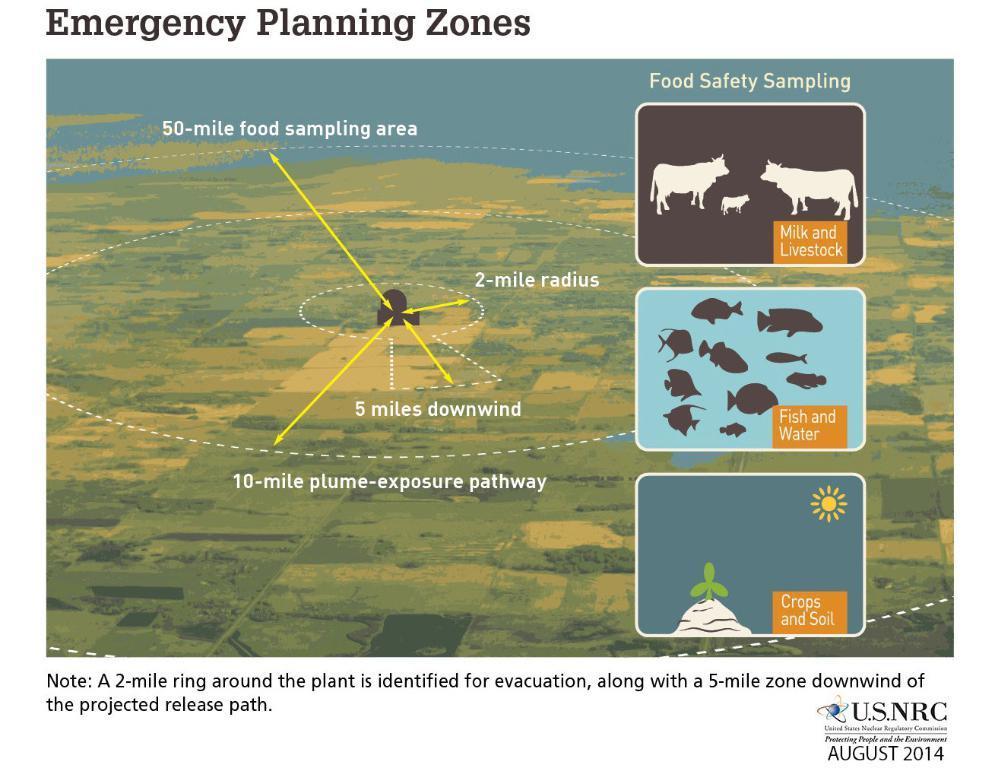Can you describe this image briefly? In this image I see the aerial view of a place and I see the water over here and I see few words written over here and here and I see the arrows and I see the depiction of cows, fishes and the small plant over here. 